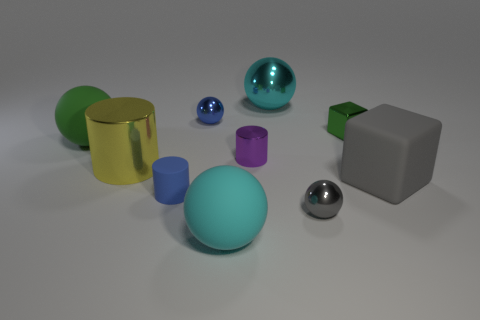Can you compare the sizes of the green sphere and the gray cube? Certainly! The green sphere is larger than the gray cube in overall volume. The sphere's curved surface allows it to occupy more three-dimensional space than the cube, which, while structured, is smaller in comparison. 